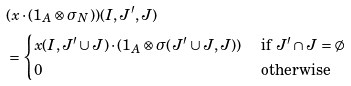Convert formula to latex. <formula><loc_0><loc_0><loc_500><loc_500>& ( x \cdot ( 1 _ { A } \otimes \sigma _ { N } ) ) ( I , J ^ { \prime } , J ) \\ & = \begin{cases} x ( I , J ^ { \prime } \cup J ) \cdot ( 1 _ { A } \otimes \sigma ( J ^ { \prime } \cup J , J ) ) & \text { if } J ^ { \prime } \cap J = \emptyset \\ 0 & \text { otherwise } \end{cases}</formula> 